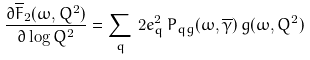Convert formula to latex. <formula><loc_0><loc_0><loc_500><loc_500>\frac { \partial \overline { F } _ { 2 } ( \omega , Q ^ { 2 } ) } { \partial \log Q ^ { 2 } } = \sum _ { q } \, 2 e _ { q } ^ { 2 } \, P _ { q g } ( \omega , \overline { \gamma } ) \, g ( \omega , Q ^ { 2 } )</formula> 